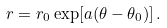<formula> <loc_0><loc_0><loc_500><loc_500>r = r _ { 0 } \exp [ a ( \theta - \theta _ { 0 } ) ] \, .</formula> 